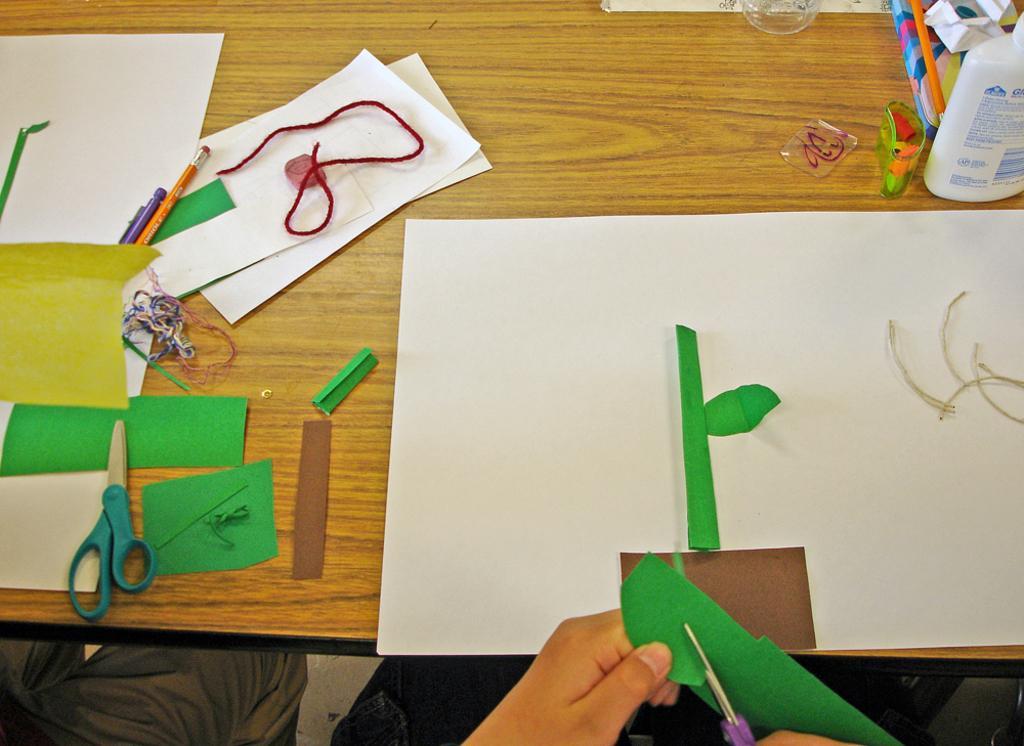Please provide a concise description of this image. In this image in the middle, there is a table on that there are papers, pens, pencils, scissors, bottle, glasses, threads. At the bottom there are some people. 